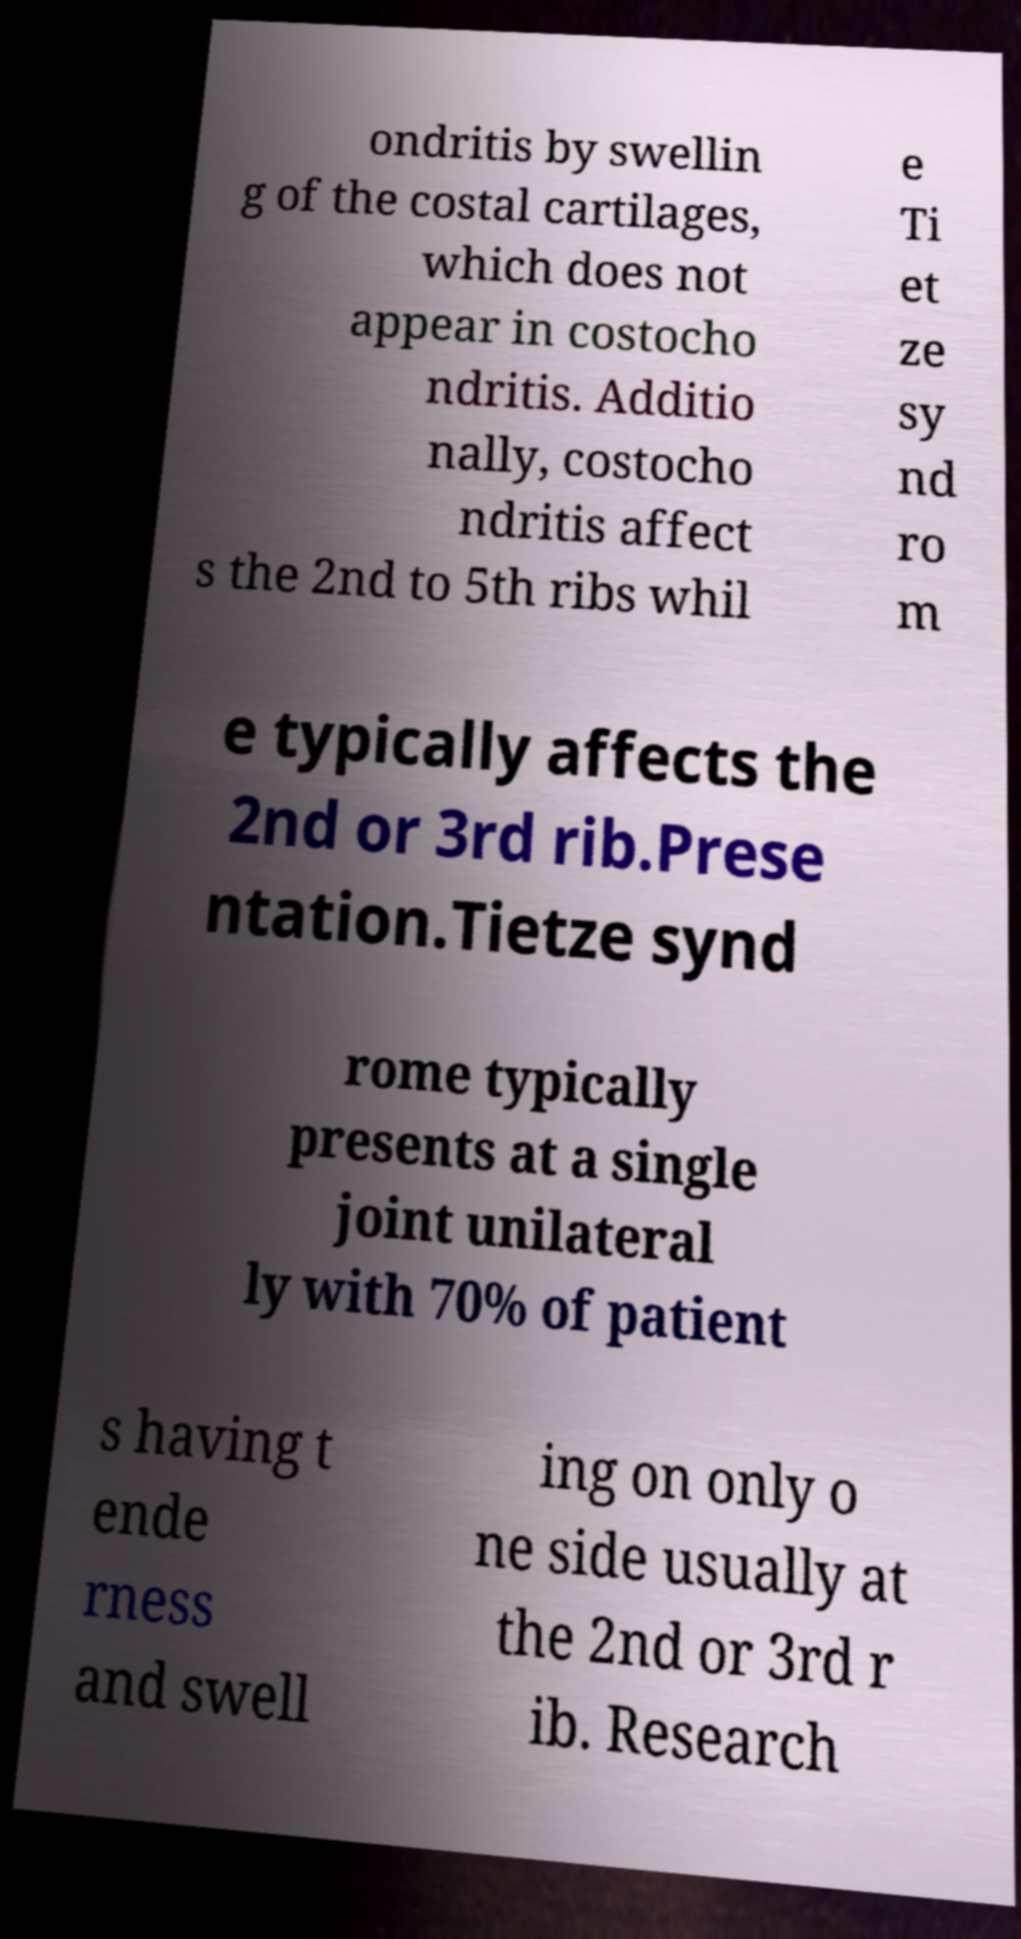There's text embedded in this image that I need extracted. Can you transcribe it verbatim? ondritis by swellin g of the costal cartilages, which does not appear in costocho ndritis. Additio nally, costocho ndritis affect s the 2nd to 5th ribs whil e Ti et ze sy nd ro m e typically affects the 2nd or 3rd rib.Prese ntation.Tietze synd rome typically presents at a single joint unilateral ly with 70% of patient s having t ende rness and swell ing on only o ne side usually at the 2nd or 3rd r ib. Research 